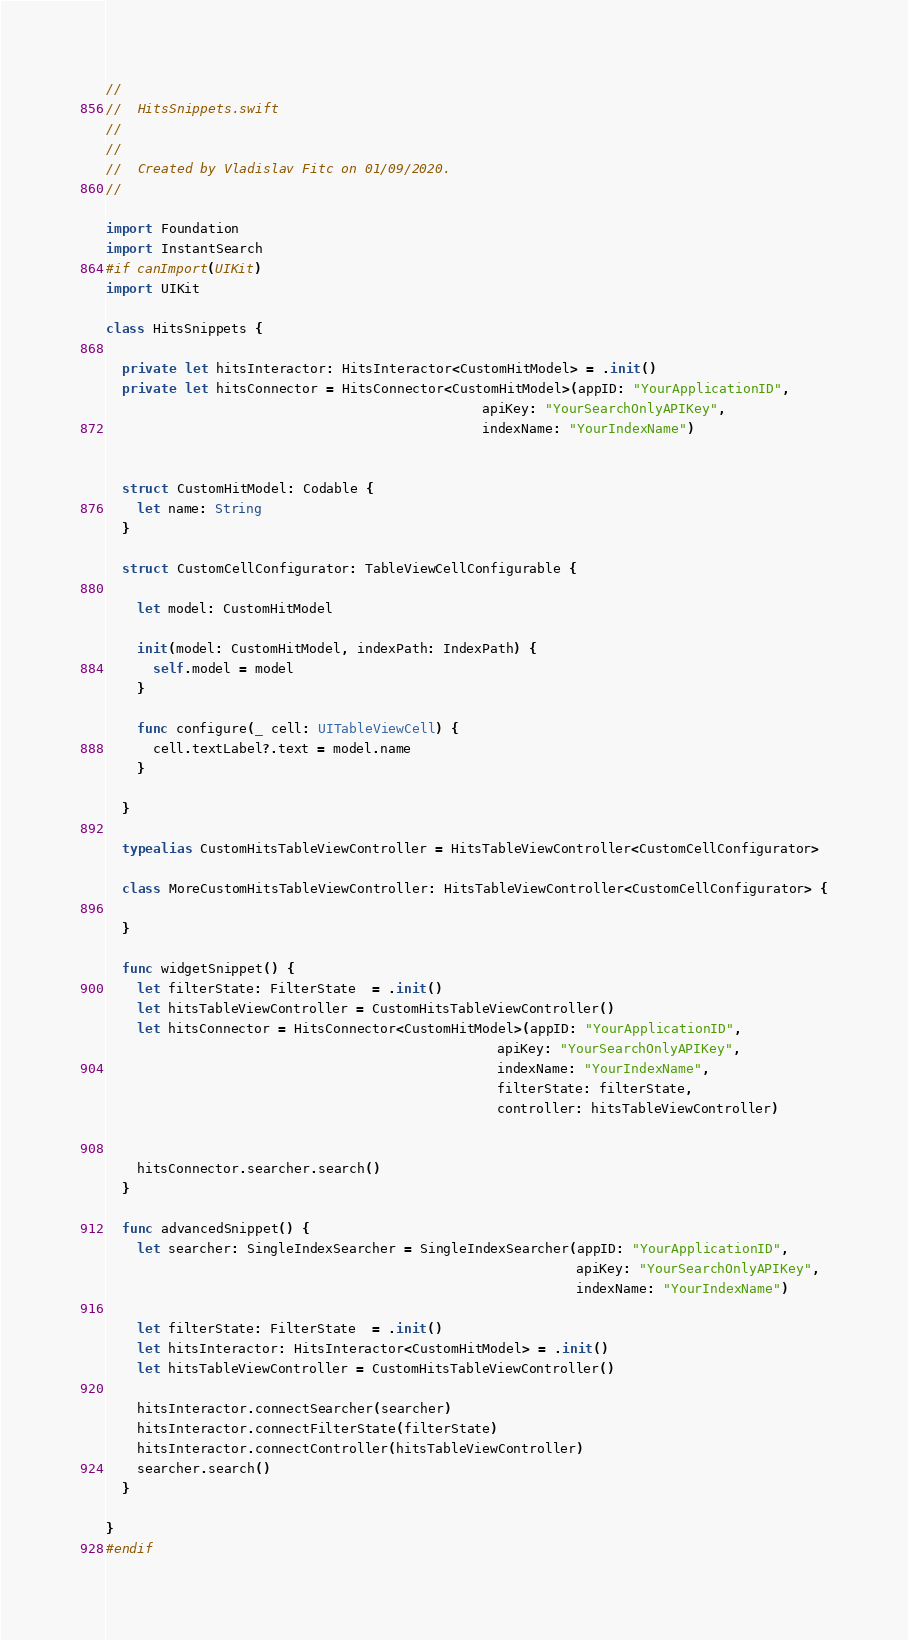<code> <loc_0><loc_0><loc_500><loc_500><_Swift_>//
//  HitsSnippets.swift
//  
//
//  Created by Vladislav Fitc on 01/09/2020.
//

import Foundation
import InstantSearch
#if canImport(UIKit)
import UIKit

class HitsSnippets {
  
  private let hitsInteractor: HitsInteractor<CustomHitModel> = .init()
  private let hitsConnector = HitsConnector<CustomHitModel>(appID: "YourApplicationID",
                                                apiKey: "YourSearchOnlyAPIKey",
                                                indexName: "YourIndexName")

  
  struct CustomHitModel: Codable {
    let name: String
  }
  
  struct CustomCellConfigurator: TableViewCellConfigurable {

    let model: CustomHitModel
    
    init(model: CustomHitModel, indexPath: IndexPath) {
      self.model = model
    }
    
    func configure(_ cell: UITableViewCell) {
      cell.textLabel?.text = model.name
    }

  }
  
  typealias CustomHitsTableViewController = HitsTableViewController<CustomCellConfigurator>
  
  class MoreCustomHitsTableViewController: HitsTableViewController<CustomCellConfigurator> {
    
  }
  
  func widgetSnippet() {
    let filterState: FilterState  = .init()
    let hitsTableViewController = CustomHitsTableViewController()
    let hitsConnector = HitsConnector<CustomHitModel>(appID: "YourApplicationID",
                                                  apiKey: "YourSearchOnlyAPIKey",
                                                  indexName: "YourIndexName",
                                                  filterState: filterState,
                                                  controller: hitsTableViewController)
    

    hitsConnector.searcher.search()
  }
  
  func advancedSnippet() {
    let searcher: SingleIndexSearcher = SingleIndexSearcher(appID: "YourApplicationID",
                                                            apiKey: "YourSearchOnlyAPIKey",
                                                            indexName: "YourIndexName")
    
    let filterState: FilterState  = .init()
    let hitsInteractor: HitsInteractor<CustomHitModel> = .init()
    let hitsTableViewController = CustomHitsTableViewController()

    hitsInteractor.connectSearcher(searcher)
    hitsInteractor.connectFilterState(filterState)
    hitsInteractor.connectController(hitsTableViewController)
    searcher.search()
  }
  
}
#endif
</code> 